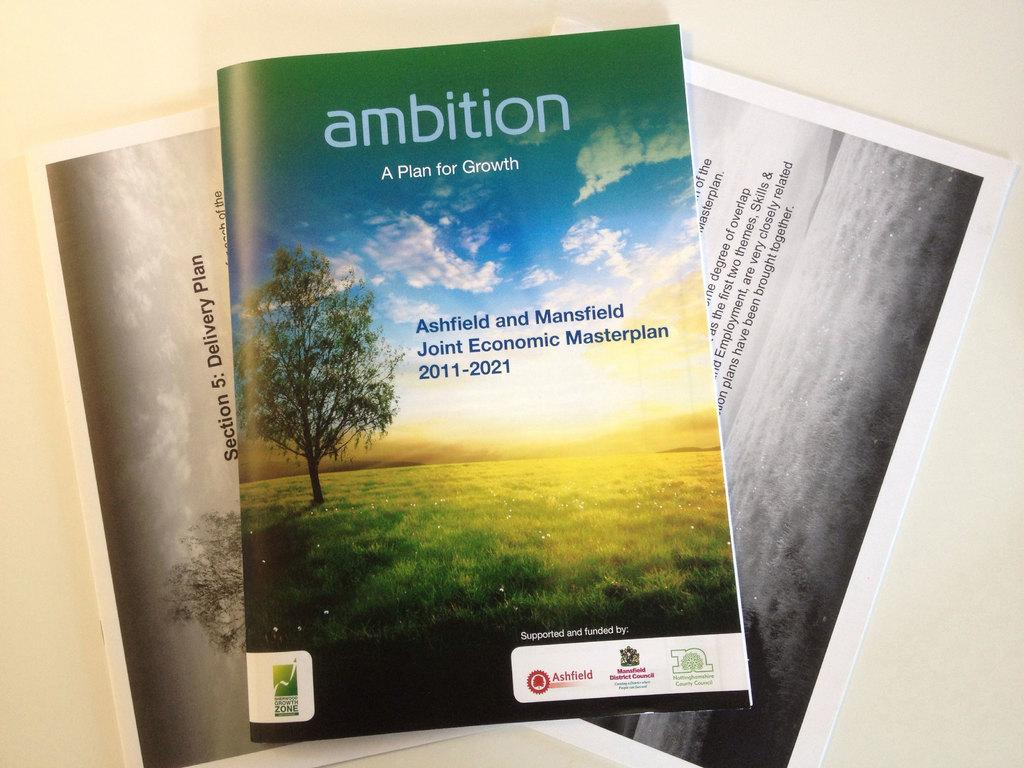<image>
Summarize the visual content of the image. Magazine book with a title of "Ambition" on the top. 